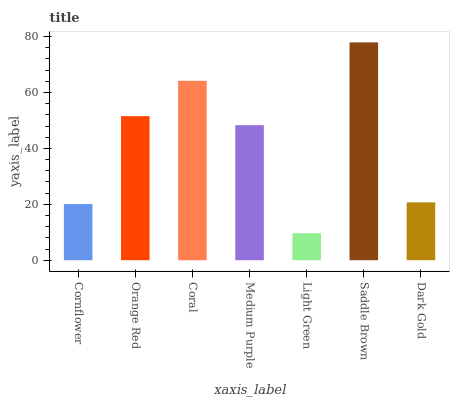Is Light Green the minimum?
Answer yes or no. Yes. Is Saddle Brown the maximum?
Answer yes or no. Yes. Is Orange Red the minimum?
Answer yes or no. No. Is Orange Red the maximum?
Answer yes or no. No. Is Orange Red greater than Cornflower?
Answer yes or no. Yes. Is Cornflower less than Orange Red?
Answer yes or no. Yes. Is Cornflower greater than Orange Red?
Answer yes or no. No. Is Orange Red less than Cornflower?
Answer yes or no. No. Is Medium Purple the high median?
Answer yes or no. Yes. Is Medium Purple the low median?
Answer yes or no. Yes. Is Dark Gold the high median?
Answer yes or no. No. Is Orange Red the low median?
Answer yes or no. No. 